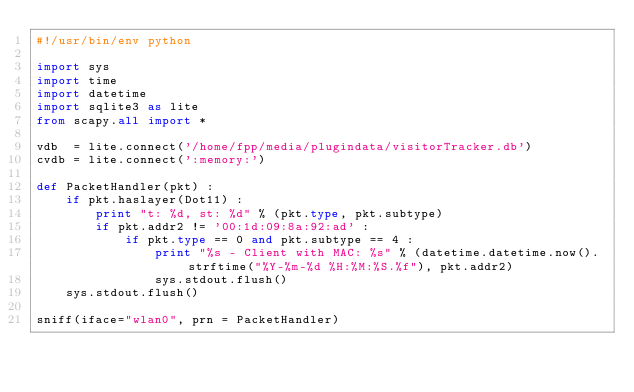<code> <loc_0><loc_0><loc_500><loc_500><_Python_>#!/usr/bin/env python

import sys
import time
import datetime
import sqlite3 as lite
from scapy.all import *

vdb  = lite.connect('/home/fpp/media/plugindata/visitorTracker.db')
cvdb = lite.connect(':memory:')

def PacketHandler(pkt) :
	if pkt.haslayer(Dot11) :
		print "t: %d, st: %d" % (pkt.type, pkt.subtype)
		if pkt.addr2 != '00:1d:09:8a:92:ad' :
			if pkt.type == 0 and pkt.subtype == 4 :
				print "%s - Client with MAC: %s" % (datetime.datetime.now().strftime("%Y-%m-%d %H:%M:%S.%f"), pkt.addr2)
				sys.stdout.flush()
	sys.stdout.flush()

sniff(iface="wlan0", prn = PacketHandler)
</code> 